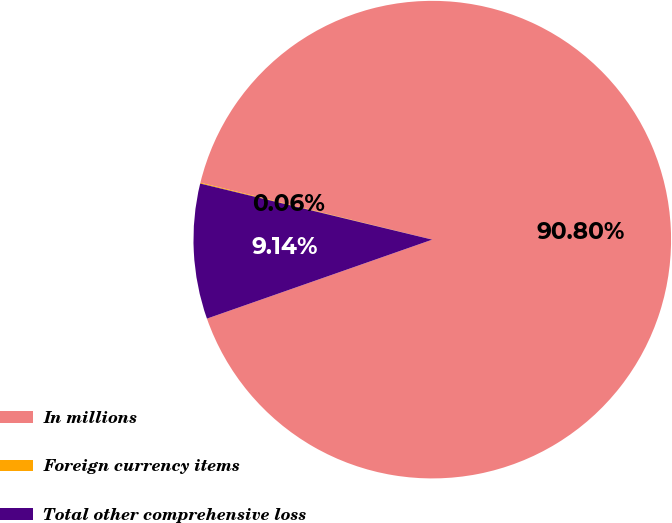Convert chart to OTSL. <chart><loc_0><loc_0><loc_500><loc_500><pie_chart><fcel>In millions<fcel>Foreign currency items<fcel>Total other comprehensive loss<nl><fcel>90.8%<fcel>0.06%<fcel>9.14%<nl></chart> 